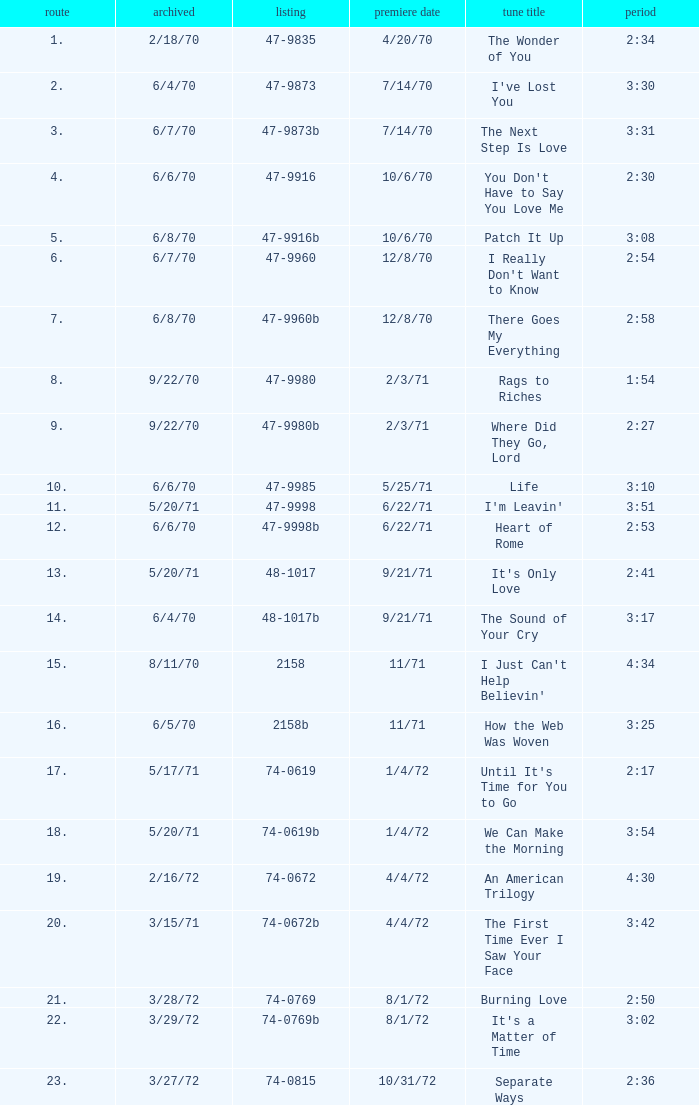What is the highest track for Burning Love? 21.0. 